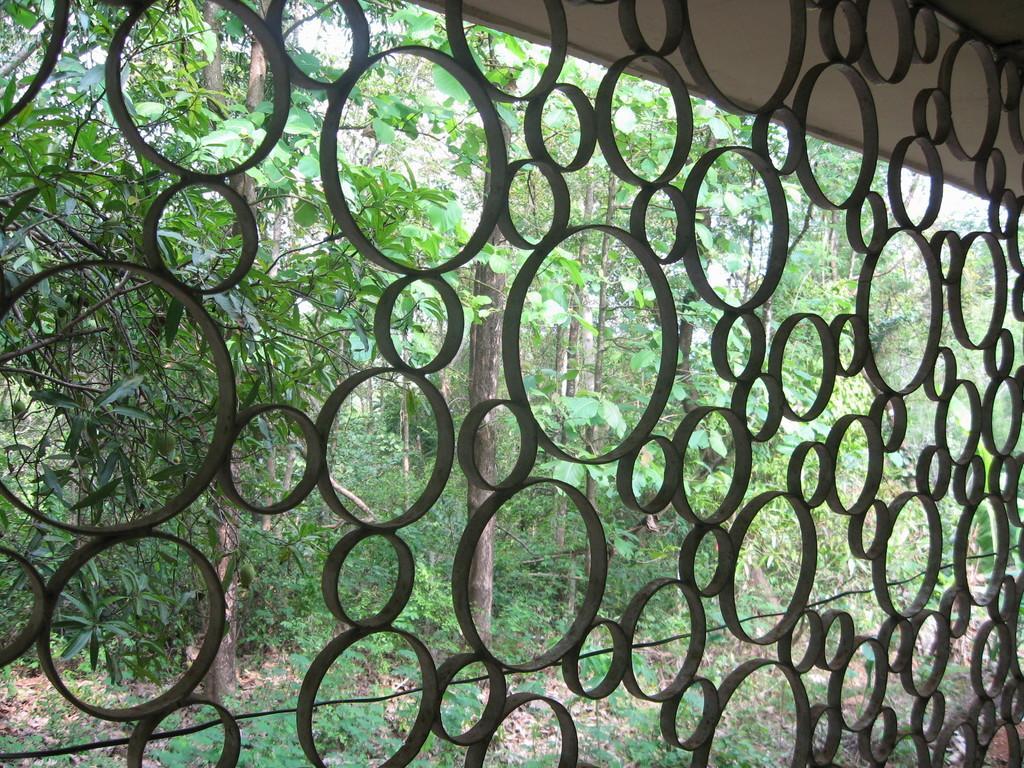Could you give a brief overview of what you see in this image? This image consists of a grill of a window. Through which we can see many trees. 